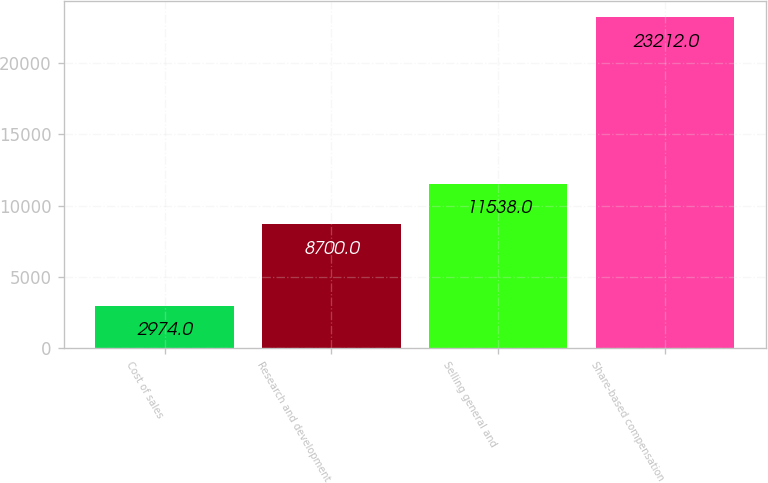Convert chart to OTSL. <chart><loc_0><loc_0><loc_500><loc_500><bar_chart><fcel>Cost of sales<fcel>Research and development<fcel>Selling general and<fcel>Share-based compensation<nl><fcel>2974<fcel>8700<fcel>11538<fcel>23212<nl></chart> 